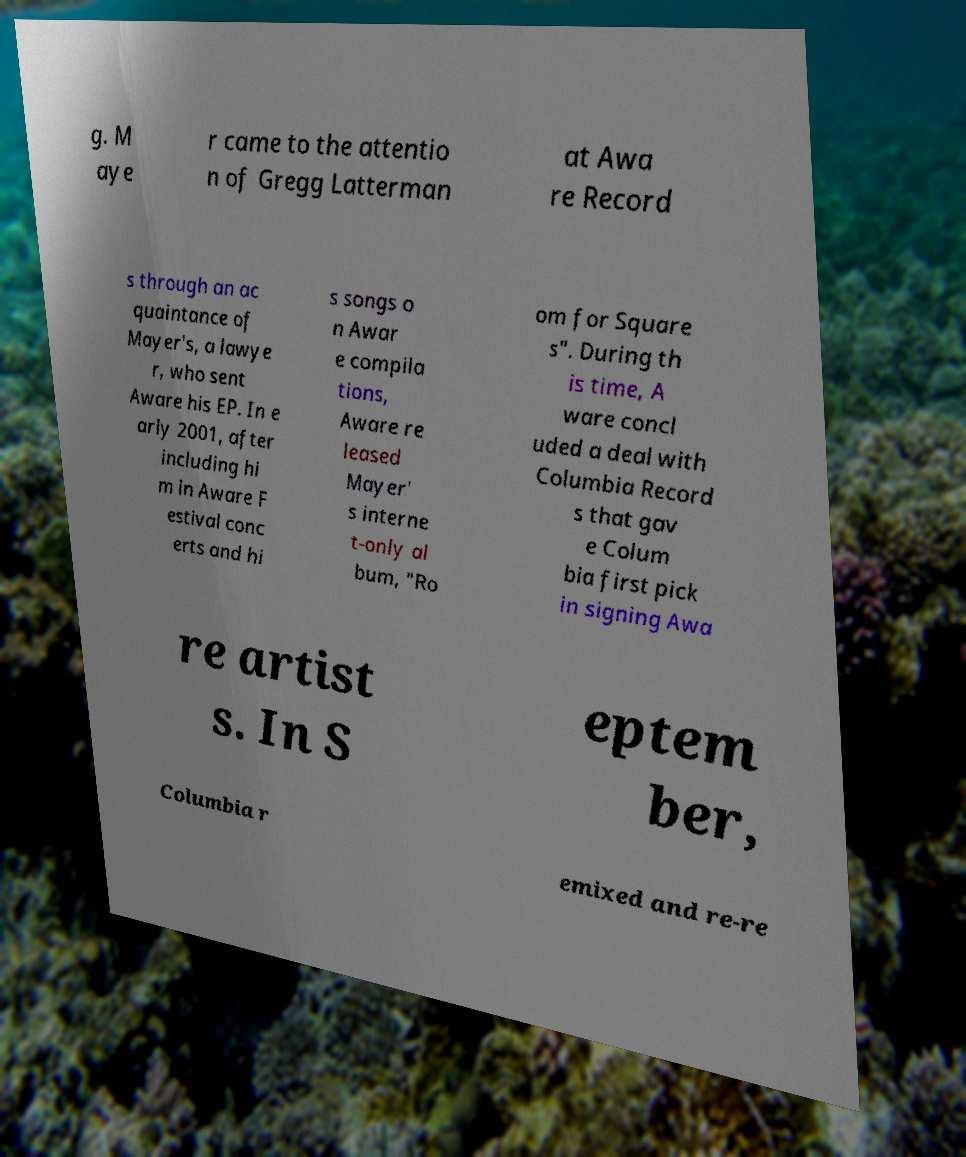Can you accurately transcribe the text from the provided image for me? g. M aye r came to the attentio n of Gregg Latterman at Awa re Record s through an ac quaintance of Mayer's, a lawye r, who sent Aware his EP. In e arly 2001, after including hi m in Aware F estival conc erts and hi s songs o n Awar e compila tions, Aware re leased Mayer' s interne t-only al bum, "Ro om for Square s". During th is time, A ware concl uded a deal with Columbia Record s that gav e Colum bia first pick in signing Awa re artist s. In S eptem ber, Columbia r emixed and re-re 